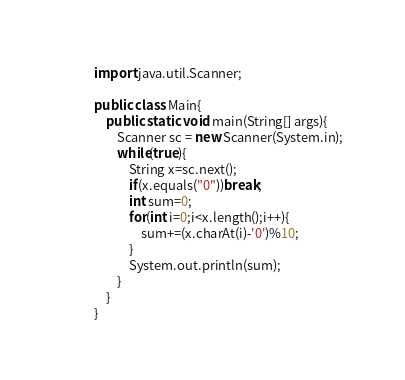Convert code to text. <code><loc_0><loc_0><loc_500><loc_500><_Java_>import java.util.Scanner;

public class Main{
    public static void main(String[] args){
        Scanner sc = new Scanner(System.in);
        while(true){
            String x=sc.next();
            if(x.equals("0"))break;
            int sum=0;
            for(int i=0;i<x.length();i++){
                sum+=(x.charAt(i)-'0')%10;
            }
            System.out.println(sum);
        }
    }
}


</code> 